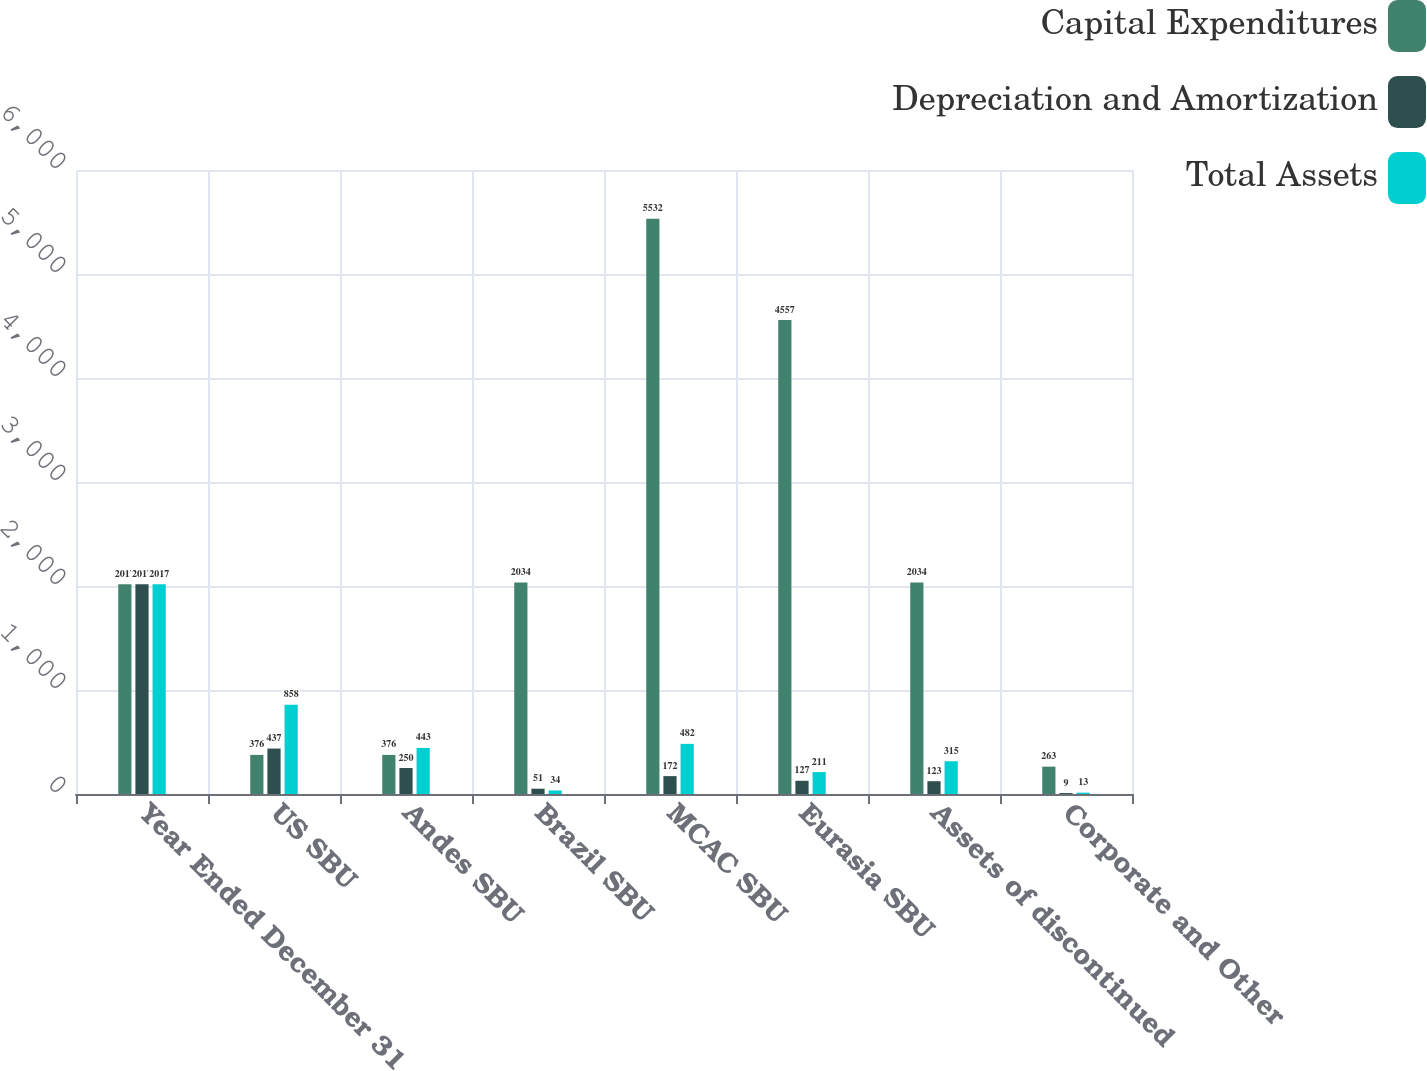Convert chart to OTSL. <chart><loc_0><loc_0><loc_500><loc_500><stacked_bar_chart><ecel><fcel>Year Ended December 31<fcel>US SBU<fcel>Andes SBU<fcel>Brazil SBU<fcel>MCAC SBU<fcel>Eurasia SBU<fcel>Assets of discontinued<fcel>Corporate and Other<nl><fcel>Capital Expenditures<fcel>2017<fcel>376<fcel>376<fcel>2034<fcel>5532<fcel>4557<fcel>2034<fcel>263<nl><fcel>Depreciation and Amortization<fcel>2017<fcel>437<fcel>250<fcel>51<fcel>172<fcel>127<fcel>123<fcel>9<nl><fcel>Total Assets<fcel>2017<fcel>858<fcel>443<fcel>34<fcel>482<fcel>211<fcel>315<fcel>13<nl></chart> 